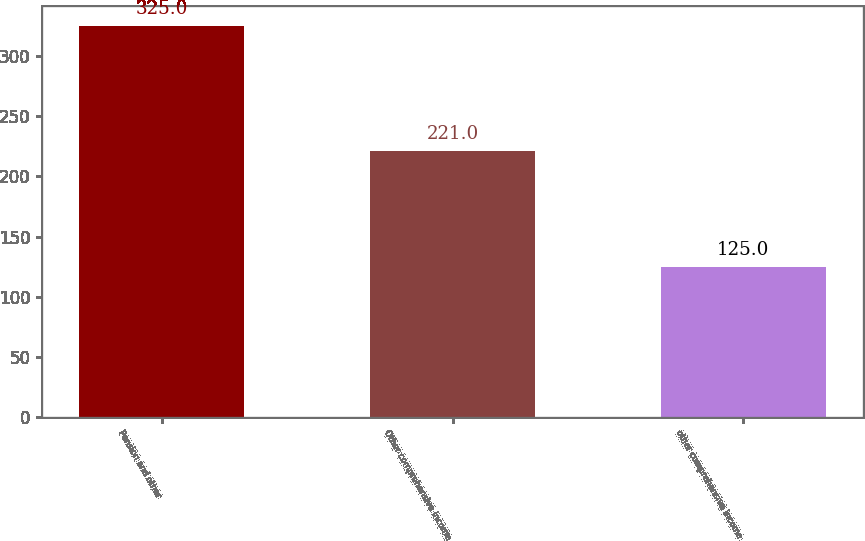<chart> <loc_0><loc_0><loc_500><loc_500><bar_chart><fcel>Pension and other<fcel>Other comprehensive income<fcel>other comprehensive income<nl><fcel>325<fcel>221<fcel>125<nl></chart> 